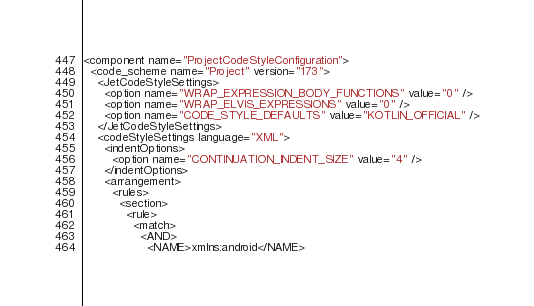<code> <loc_0><loc_0><loc_500><loc_500><_XML_><component name="ProjectCodeStyleConfiguration">
  <code_scheme name="Project" version="173">
    <JetCodeStyleSettings>
      <option name="WRAP_EXPRESSION_BODY_FUNCTIONS" value="0" />
      <option name="WRAP_ELVIS_EXPRESSIONS" value="0" />
      <option name="CODE_STYLE_DEFAULTS" value="KOTLIN_OFFICIAL" />
    </JetCodeStyleSettings>
    <codeStyleSettings language="XML">
      <indentOptions>
        <option name="CONTINUATION_INDENT_SIZE" value="4" />
      </indentOptions>
      <arrangement>
        <rules>
          <section>
            <rule>
              <match>
                <AND>
                  <NAME>xmlns:android</NAME></code> 